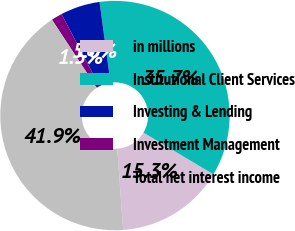<chart> <loc_0><loc_0><loc_500><loc_500><pie_chart><fcel>in millions<fcel>Institutional Client Services<fcel>Investing & Lending<fcel>Investment Management<fcel>Total net interest income<nl><fcel>15.3%<fcel>35.71%<fcel>5.57%<fcel>1.54%<fcel>41.88%<nl></chart> 